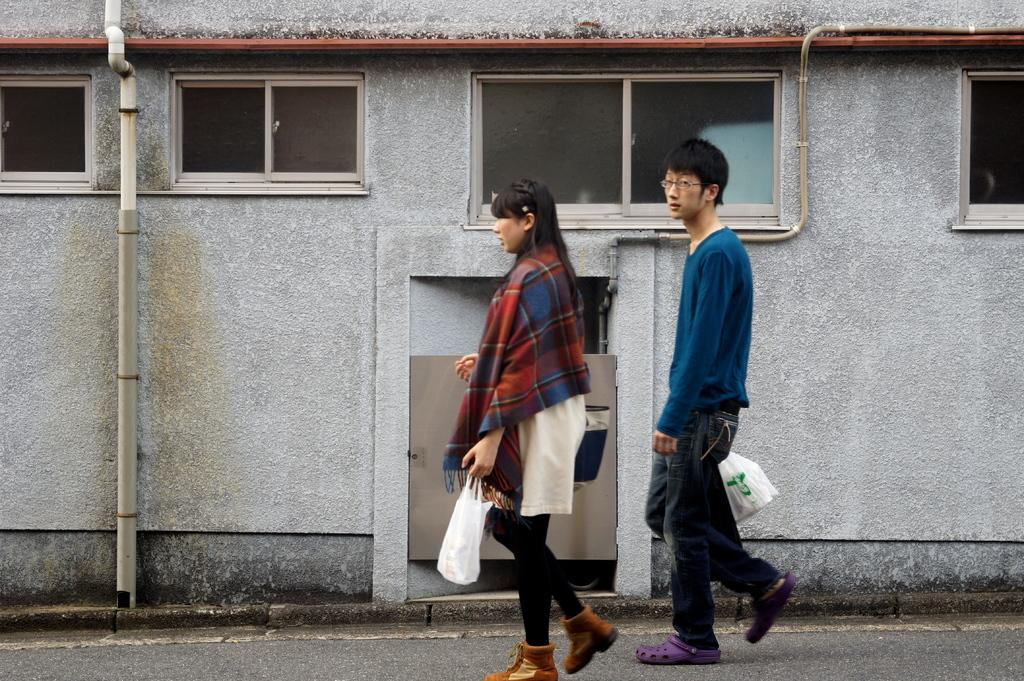What are the two people in the image doing? The two people in the image are walking on the road. What are the people holding while walking? The people are holding covers. What can be seen in the background of the image? There is a building with glass windows in the background. What letters are being discussed by the committee in the image? There is no committee or discussion of letters present in the image. 